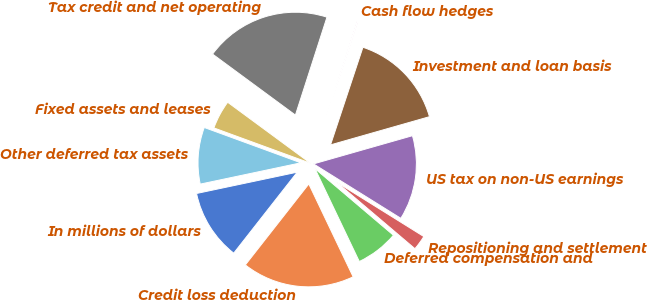Convert chart to OTSL. <chart><loc_0><loc_0><loc_500><loc_500><pie_chart><fcel>In millions of dollars<fcel>Credit loss deduction<fcel>Deferred compensation and<fcel>Repositioning and settlement<fcel>US tax on non-US earnings<fcel>Investment and loan basis<fcel>Cash flow hedges<fcel>Tax credit and net operating<fcel>Fixed assets and leases<fcel>Other deferred tax assets<nl><fcel>11.1%<fcel>17.67%<fcel>6.71%<fcel>2.33%<fcel>13.29%<fcel>15.48%<fcel>0.14%<fcel>19.86%<fcel>4.52%<fcel>8.9%<nl></chart> 